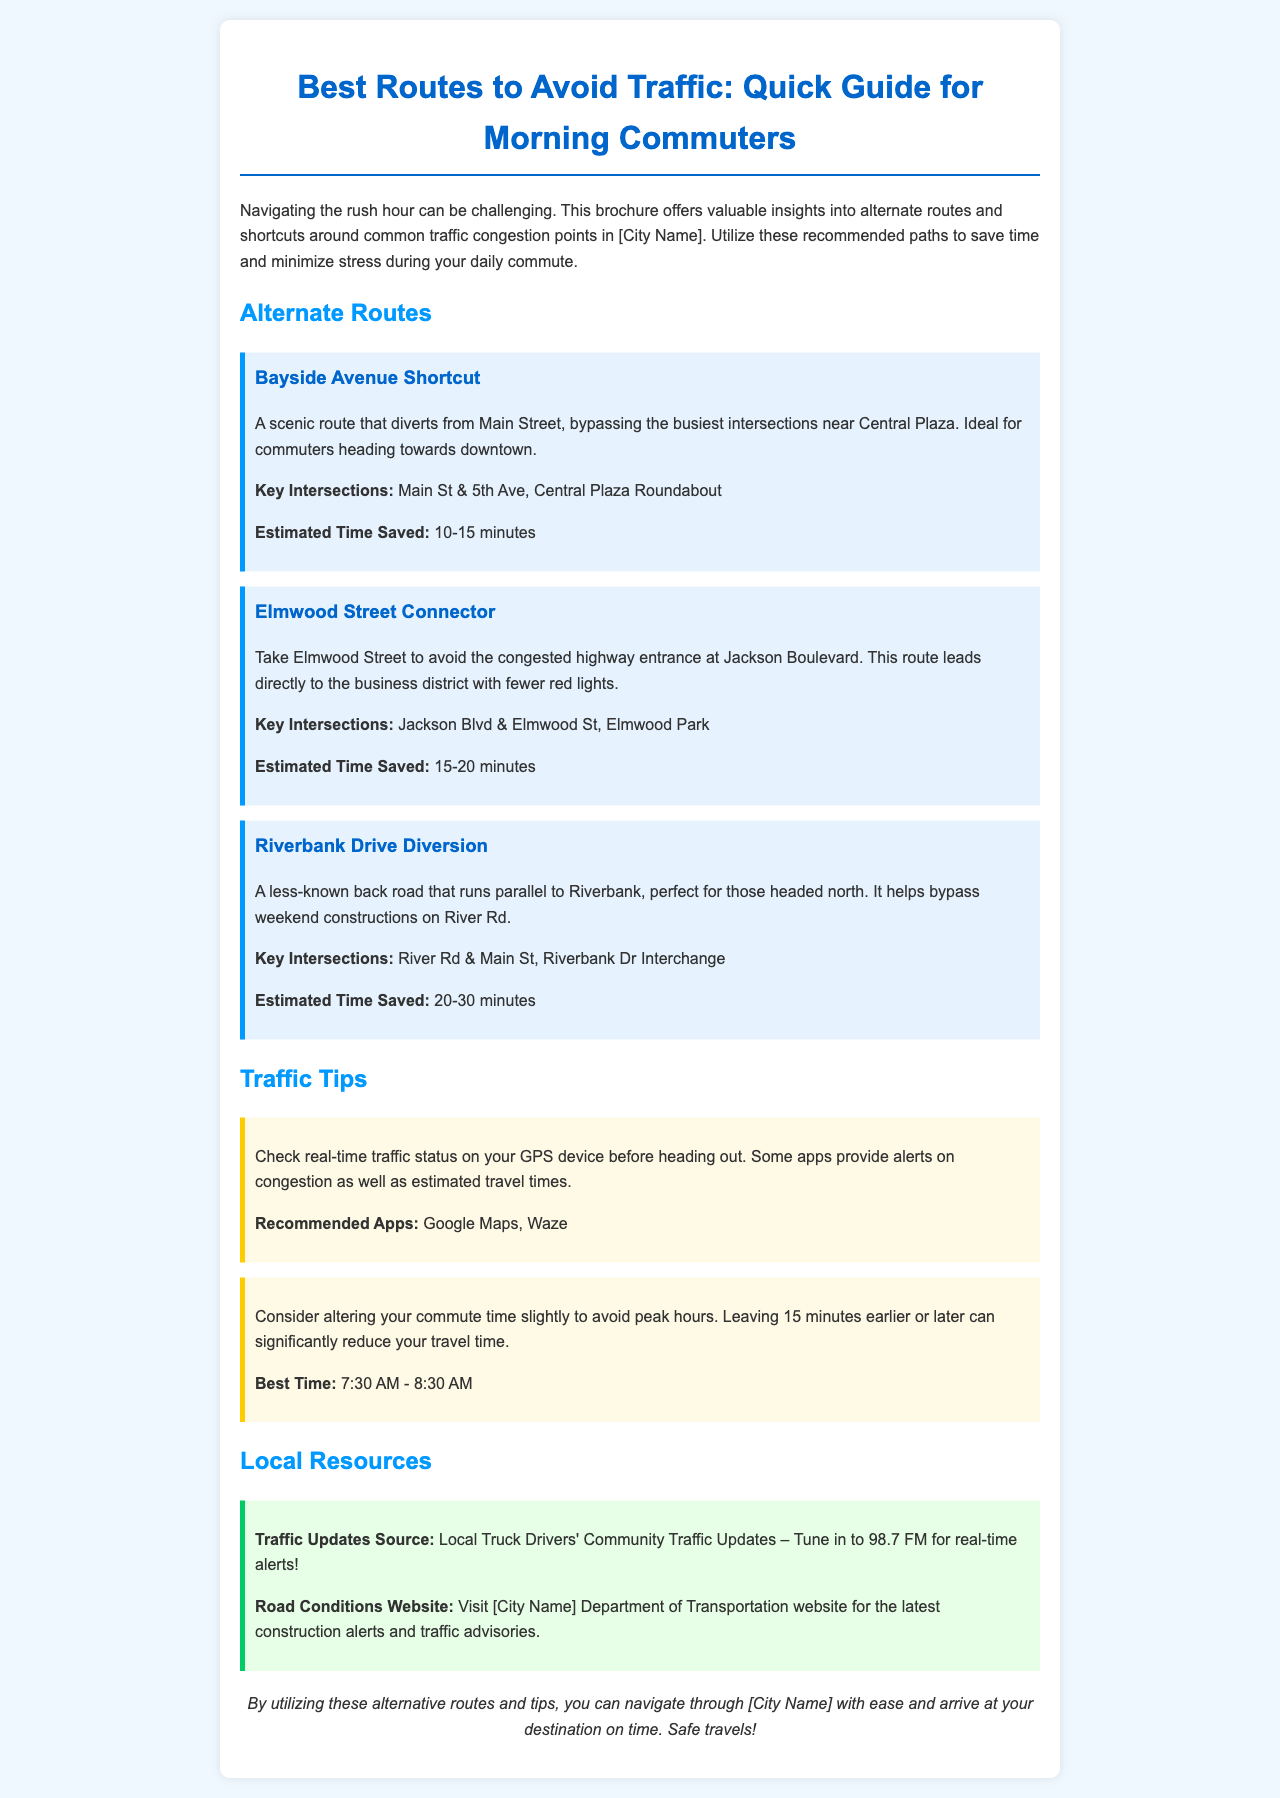What is the title of the brochure? The title is found at the top of the document and describes its purpose for commuters.
Answer: Best Routes to Avoid Traffic: Quick Guide for Morning Commuters What is the estimated time saved by the Bayside Avenue Shortcut? The brochure gives specific estimated time savings for each route under their descriptions.
Answer: 10-15 minutes What is a recommended app for checking real-time traffic status? The tips section lists apps that are useful for commuters; one of them pertains to traffic tracking.
Answer: Google Maps What is the best time to commute to avoid peak hours? The tips section provides advice on optimal commuting times, focusing on when to leave for less congestion.
Answer: 7:30 AM - 8:30 AM Which route helps avoid the congested highway entrance at Jackson Boulevard? This can be found in the descriptions of the alternate routes; it identifies routes along with their purposes.
Answer: Elmwood Street Connector What local resource provides real-time traffic updates? The resources section specifies where commuters can receive current traffic information, relevant for planning their trips.
Answer: Local Truck Drivers' Community Traffic Updates What is the estimated time saved by the Riverbank Drive Diversion? The estimated time saved for each route is shared in the brochure, helping commuters with timing considerations.
Answer: 20-30 minutes Which route is ideal for commuters heading towards downtown? The brochure specifies the purpose of each route, indicating their suitability for different directions.
Answer: Bayside Avenue Shortcut 